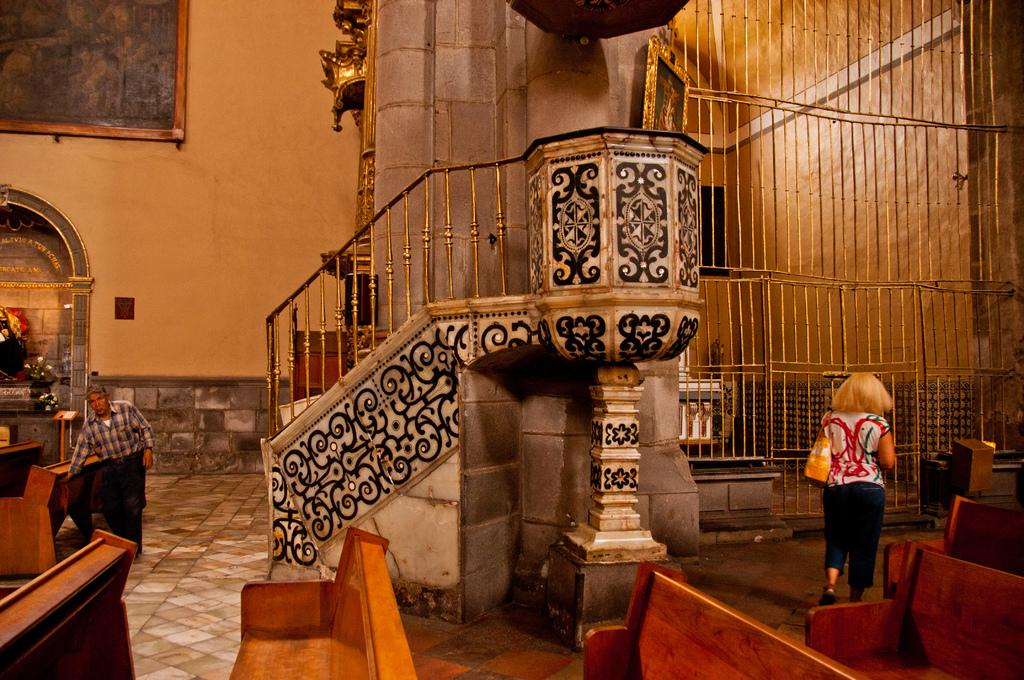How many persons are on the floor in the image? There are two persons on the floor in the image. What type of furniture can be seen in the image? There are benches in the image. What architectural feature is present in the image? There is a pillar in the image. What can be used for climbing or descending in the image? There is a staircase in the image. What type of artwork is present on a wall in the image? There is a wall painting on a wall in the image. What devices are present for amplifying sound in the image? There are speakers in the image. What other objects can be seen in the image? There are some objects in the image. What type of building might the image have been taken in? The image may have been taken in a church. What type of animal is present in the image, and where is it located? There is no animal present in the image. What part of the body is the hen touching in the image? There is no hen present in the image, so it cannot be touching any part of its body. 